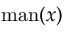Convert formula to latex. <formula><loc_0><loc_0><loc_500><loc_500>{ m a n } ( x )</formula> 